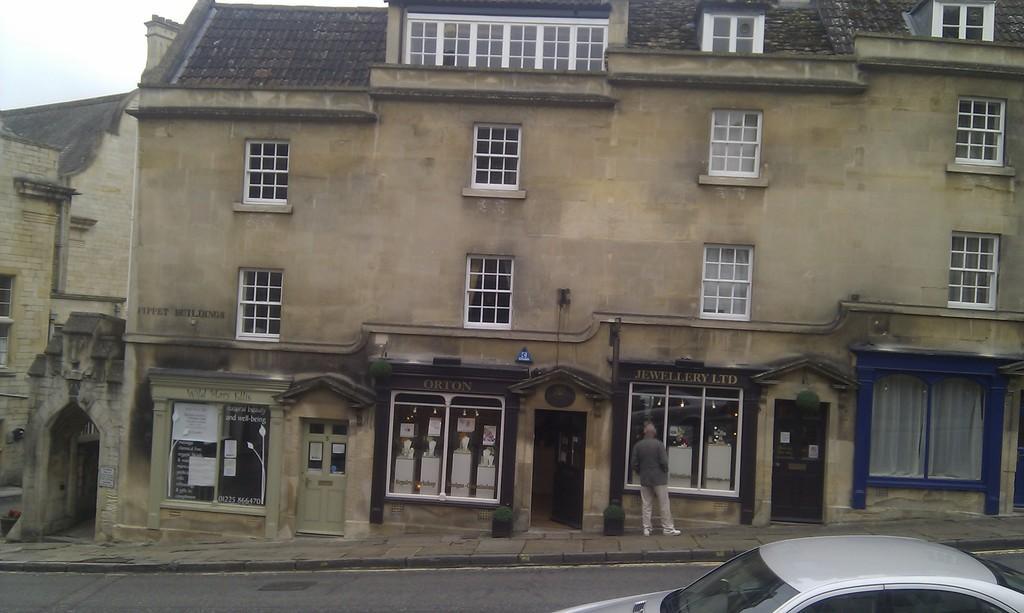In one or two sentences, can you explain what this image depicts? In this image we can see buildings, a person is standing on the pavement in front of the building and there are few posters with text on the building and there is a car on the road. 